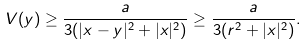<formula> <loc_0><loc_0><loc_500><loc_500>V ( y ) \geq \frac { a } { 3 ( | x - y | ^ { 2 } + | x | ^ { 2 } ) } \geq \frac { a } { 3 ( r ^ { 2 } + | x | ^ { 2 } ) } .</formula> 